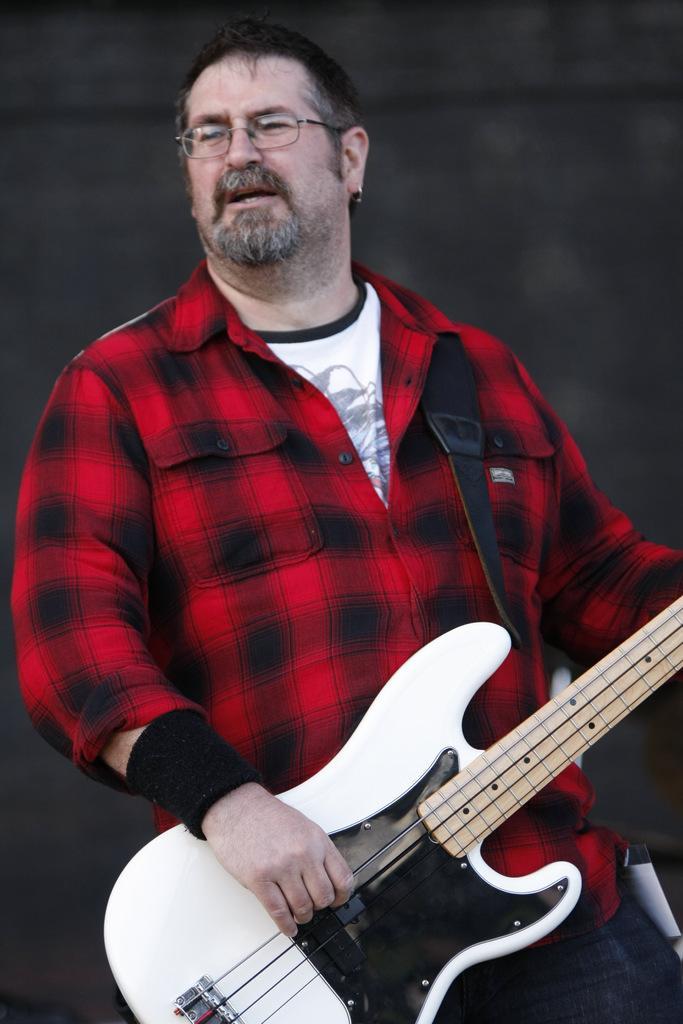Can you describe this image briefly? In this image i can see a person wearing a red dress, holding a guitar in his hand. 